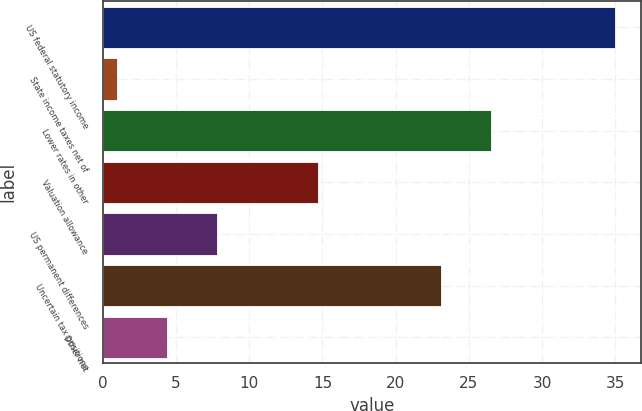Convert chart to OTSL. <chart><loc_0><loc_0><loc_500><loc_500><bar_chart><fcel>US federal statutory income<fcel>State income taxes net of<fcel>Lower rates in other<fcel>Valuation allowance<fcel>US permanent differences<fcel>Uncertain tax positions<fcel>Other net<nl><fcel>35<fcel>1<fcel>26.5<fcel>14.7<fcel>7.8<fcel>23.1<fcel>4.4<nl></chart> 